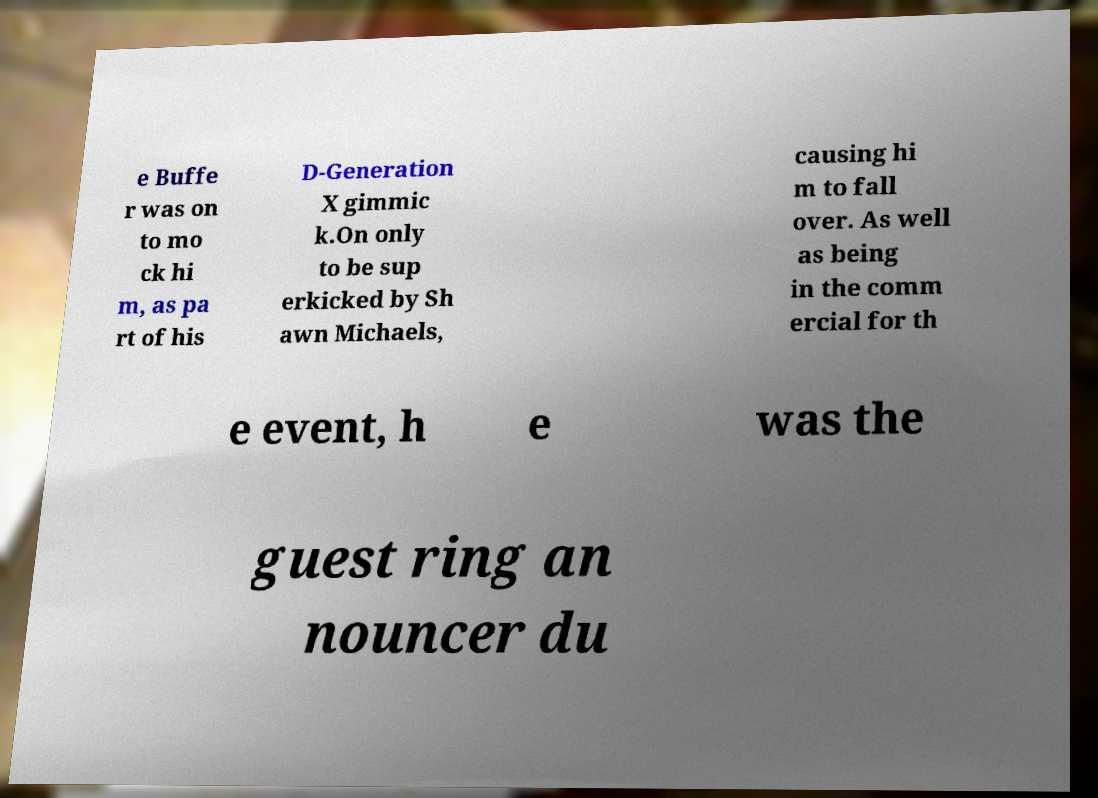I need the written content from this picture converted into text. Can you do that? e Buffe r was on to mo ck hi m, as pa rt of his D-Generation X gimmic k.On only to be sup erkicked by Sh awn Michaels, causing hi m to fall over. As well as being in the comm ercial for th e event, h e was the guest ring an nouncer du 